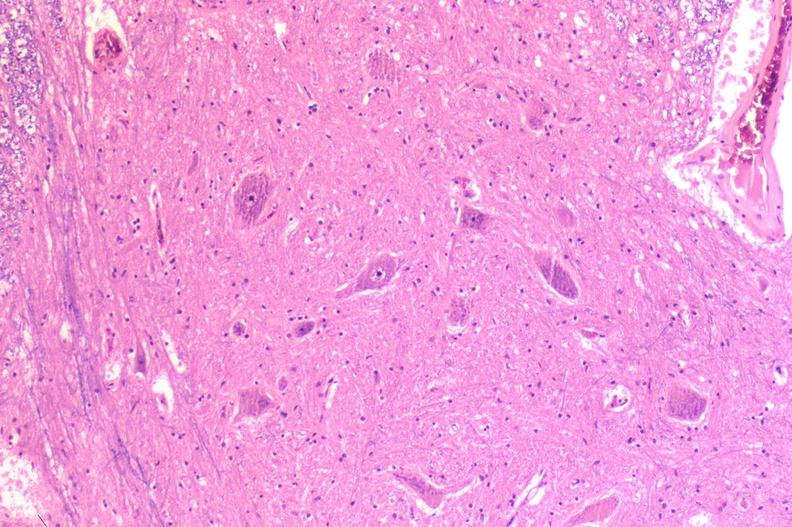why does this image show spinal cord injury?
Answer the question using a single word or phrase. Due to vertebral column trauma 